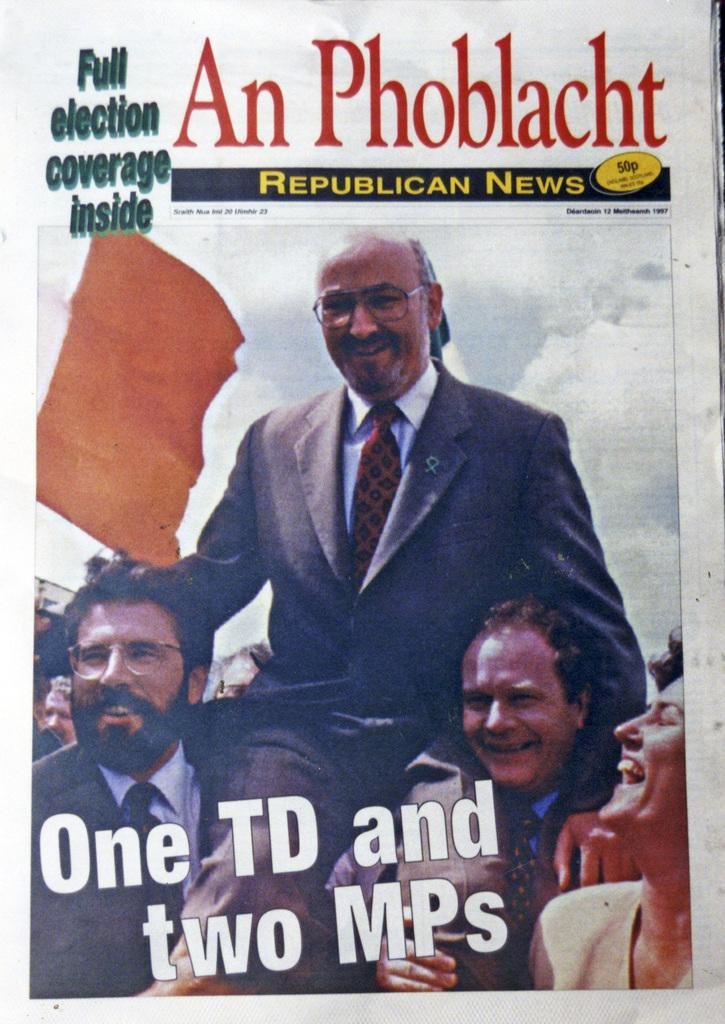What is the main subject of the image? The main subject of the image is a magazine cover page. How many people are featured on the magazine cover? There are four persons on the magazine cover. What else can be seen on the magazine cover besides the people? There is text written on the magazine cover. What type of shade is covering the magazine cover in the image? There is no shade covering the magazine cover in the image; it is fully visible. 